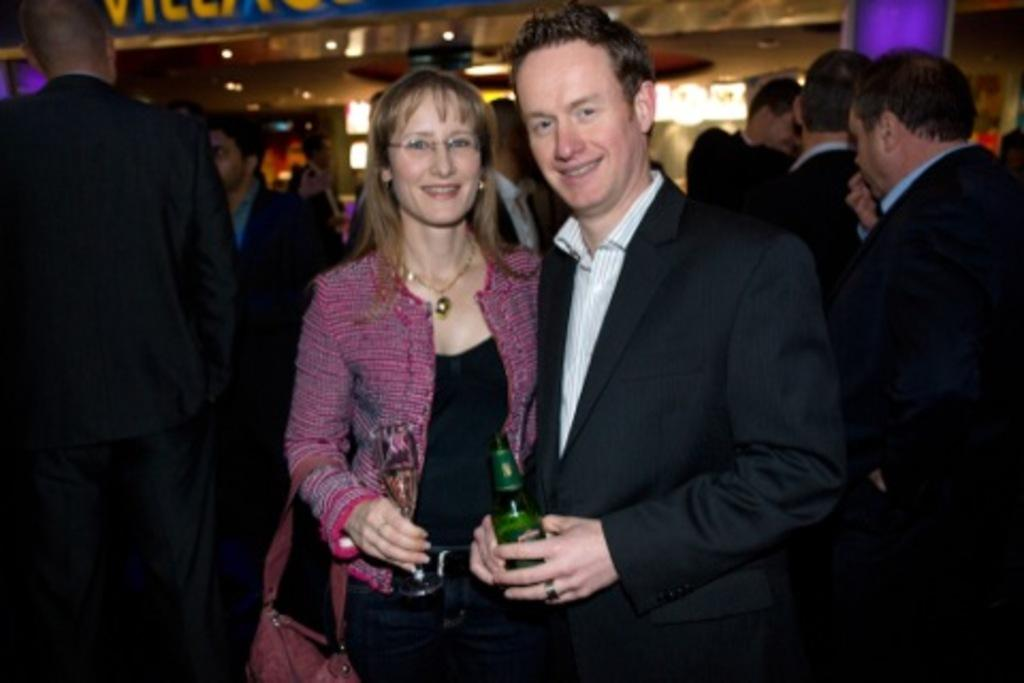Who are the main subjects in the foreground of the image? There is a woman and a man in the foreground of the image. What are the expressions on their faces? Both the woman and man are smiling. What are they holding in their hands? The woman and man are holding bottles. What can be seen in the background of the image? There is a group of people and lights visible in the background of the image. What type of hen can be seen in the image? There is no hen present in the image. What is the maid doing in the image? There is no maid present in the image. 